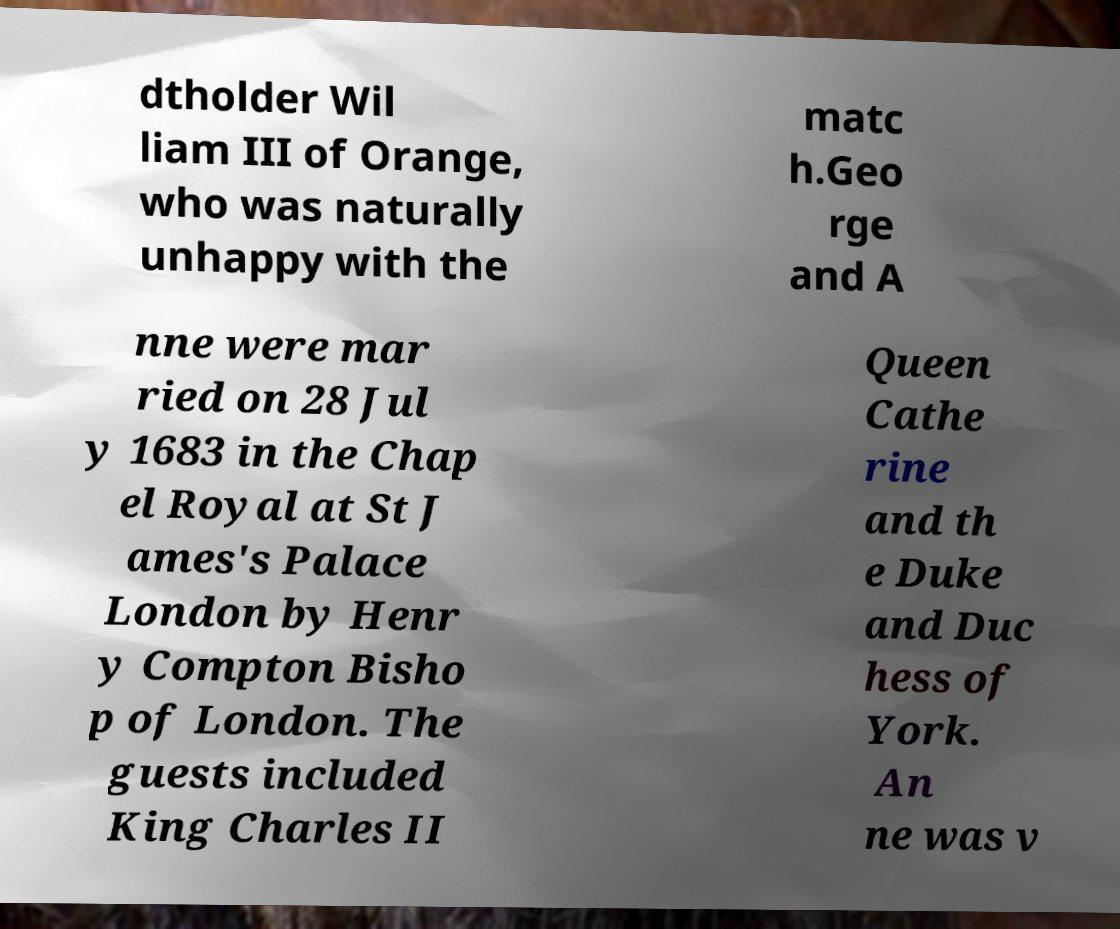Can you accurately transcribe the text from the provided image for me? dtholder Wil liam III of Orange, who was naturally unhappy with the matc h.Geo rge and A nne were mar ried on 28 Jul y 1683 in the Chap el Royal at St J ames's Palace London by Henr y Compton Bisho p of London. The guests included King Charles II Queen Cathe rine and th e Duke and Duc hess of York. An ne was v 